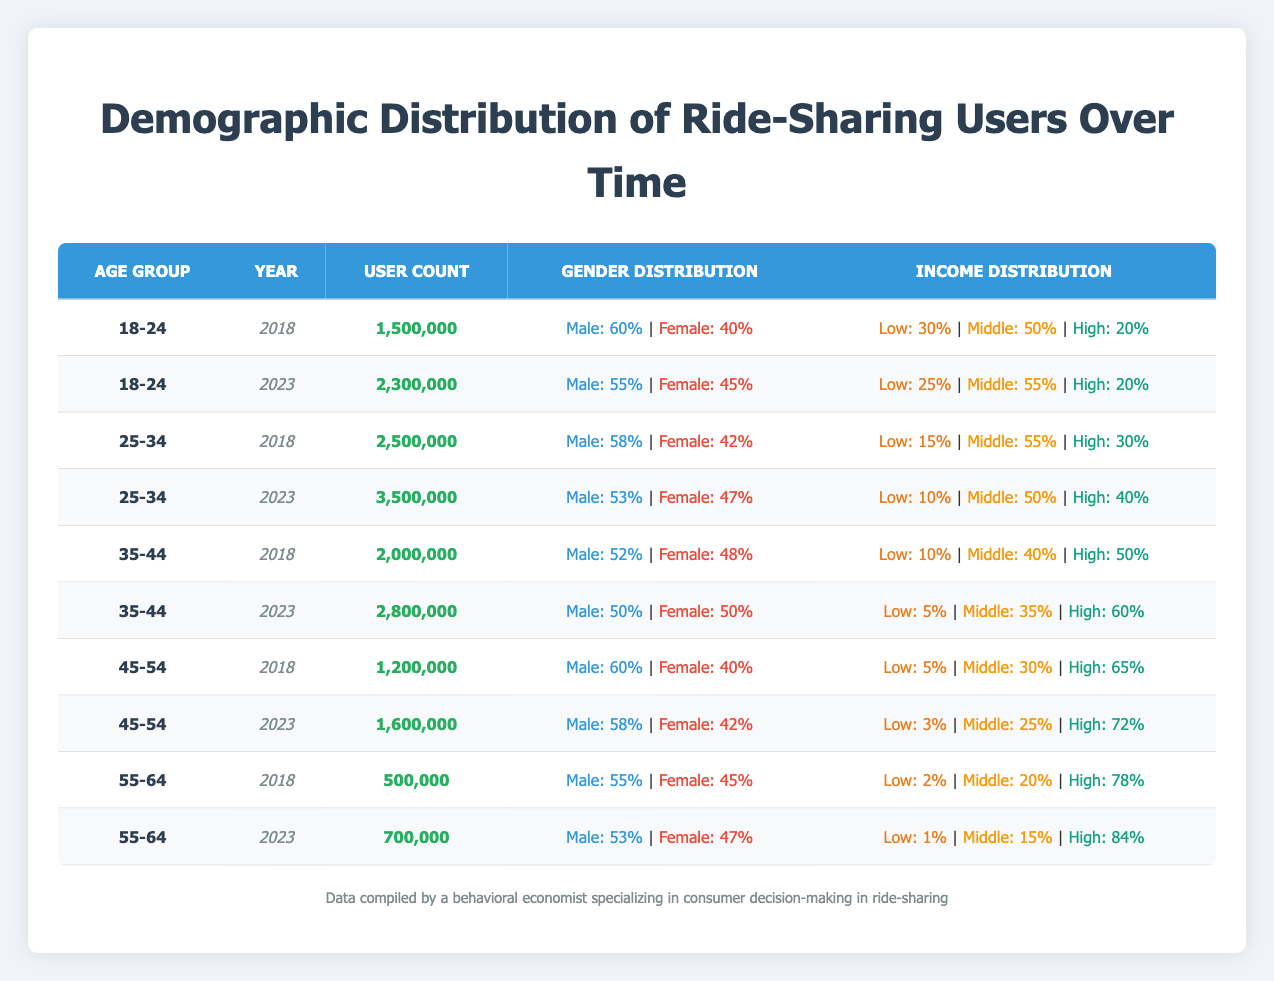What was the user count for the age group 25-34 in 2018? The table indicates that the user count for the age group 25-34 in the year 2018 is 2,500,000.
Answer: 2,500,000 What percentage of ride-sharing users aged 35-44 were female in 2023? Referring to the data for the age group 35-44 in 2023, the gender distribution shows that 50% of users were female.
Answer: 50% What is the total user count for all age groups in 2023? By adding the user counts from each age group in the year 2023: 2,300,000 (18-24) + 3,500,000 (25-34) + 2,800,000 (35-44) + 1,600,000 (45-54) + 700,000 (55-64) = 11,900,000.
Answer: 11,900,000 Is the percentage of low-income ride-sharing users in 2023 lower than in 2018 for all age groups? Comparing the low-income percentages across all age groups: 18-24 (25% vs 30%), 25-34 (10% vs 15%), 35-44 (5% vs 10%), 45-54 (3% vs 5%), and 55-64 (1% vs 2%), we see that all have lower low-income percentages in 2023.
Answer: Yes What is the percentage increase in user count for the age group 45-54 from 2018 to 2023? The user count for the age group 45-54 in 2018 was 1,200,000, and in 2023 it was 1,600,000. The increase is 1,600,000 - 1,200,000 = 400,000. The percentage increase is (400,000 / 1,200,000) * 100 = 33.33%.
Answer: 33.33% 